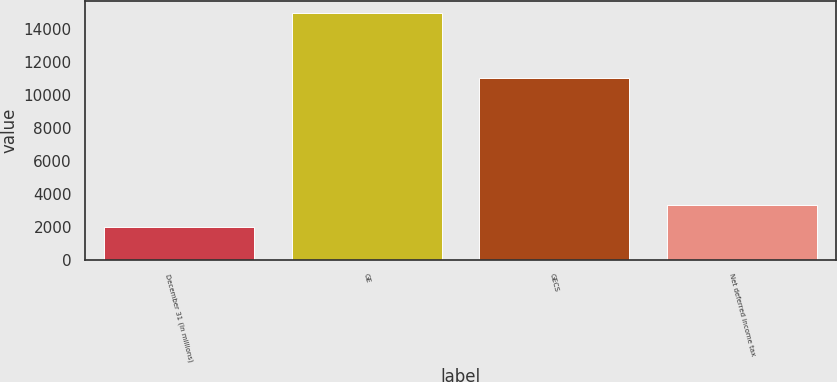Convert chart. <chart><loc_0><loc_0><loc_500><loc_500><bar_chart><fcel>December 31 (In millions)<fcel>GE<fcel>GECS<fcel>Net deferred income tax<nl><fcel>2009<fcel>14945<fcel>11008<fcel>3302.6<nl></chart> 